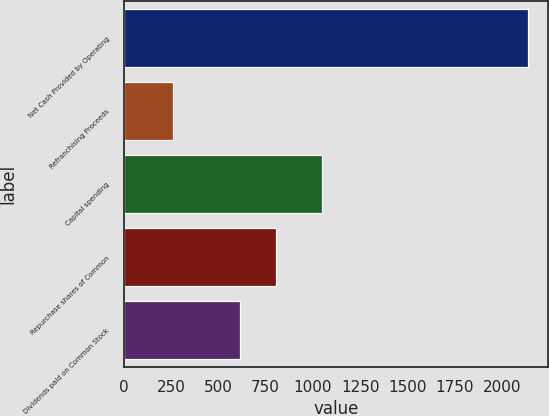Convert chart to OTSL. <chart><loc_0><loc_0><loc_500><loc_500><bar_chart><fcel>Net Cash Provided by Operating<fcel>Refranchising Proceeds<fcel>Capital spending<fcel>Repurchase shares of Common<fcel>Dividends paid on Common Stock<nl><fcel>2139<fcel>260<fcel>1049<fcel>802.9<fcel>615<nl></chart> 